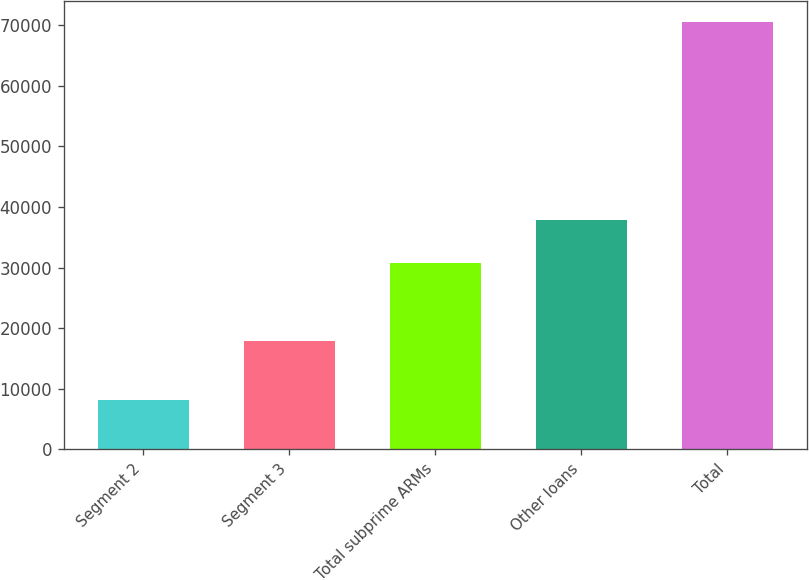Convert chart to OTSL. <chart><loc_0><loc_0><loc_500><loc_500><bar_chart><fcel>Segment 2<fcel>Segment 3<fcel>Total subprime ARMs<fcel>Other loans<fcel>Total<nl><fcel>8114<fcel>17817<fcel>30806<fcel>37891<fcel>70535<nl></chart> 